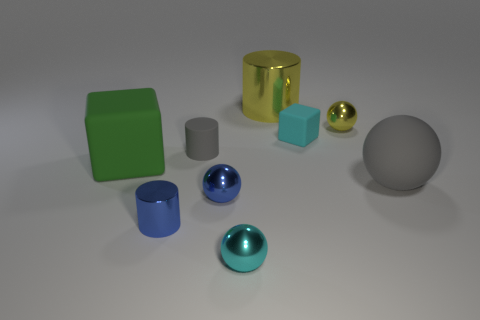Is the number of small blue shiny things that are in front of the tiny blue cylinder the same as the number of large yellow shiny objects?
Ensure brevity in your answer.  No. Is the big metal cylinder the same color as the large matte block?
Give a very brief answer. No. What size is the object that is to the left of the small gray object and in front of the large gray matte ball?
Offer a very short reply. Small. What is the color of the big cylinder that is the same material as the small yellow sphere?
Offer a terse response. Yellow. How many gray spheres are the same material as the big green thing?
Offer a terse response. 1. Is the number of things behind the big yellow shiny cylinder the same as the number of small cyan spheres in front of the tiny block?
Make the answer very short. No. Does the small cyan metallic object have the same shape as the gray object that is in front of the green matte object?
Your answer should be very brief. Yes. There is a small thing that is the same color as the big shiny cylinder; what is its material?
Give a very brief answer. Metal. Is there any other thing that has the same shape as the cyan shiny thing?
Provide a short and direct response. Yes. Is the material of the gray sphere the same as the tiny cylinder that is in front of the gray cylinder?
Your response must be concise. No. 